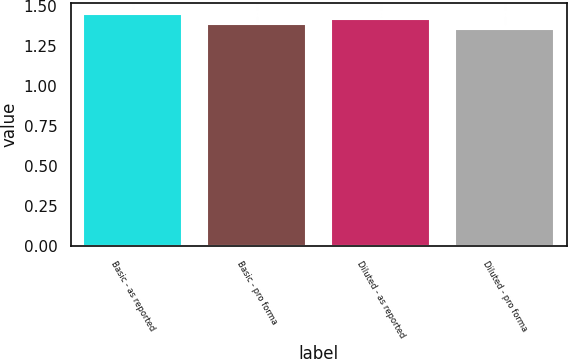Convert chart. <chart><loc_0><loc_0><loc_500><loc_500><bar_chart><fcel>Basic - as reported<fcel>Basic - pro forma<fcel>Diluted - as reported<fcel>Diluted - pro forma<nl><fcel>1.45<fcel>1.39<fcel>1.42<fcel>1.36<nl></chart> 